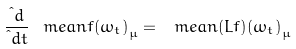Convert formula to latex. <formula><loc_0><loc_0><loc_500><loc_500>\frac { \i d } { \i d t } \ m e a n { f ( \omega _ { t } ) } _ { \mu } = \ m e a n { ( L f ) ( \omega _ { t } ) } _ { \mu }</formula> 